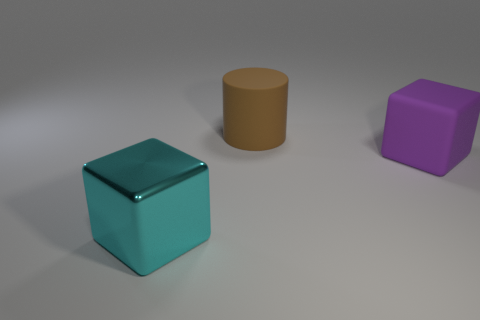Add 3 rubber things. How many objects exist? 6 Subtract all blocks. How many objects are left? 1 Add 3 large cubes. How many large cubes exist? 5 Subtract 1 purple blocks. How many objects are left? 2 Subtract all small cyan metallic cylinders. Subtract all large purple cubes. How many objects are left? 2 Add 1 cyan things. How many cyan things are left? 2 